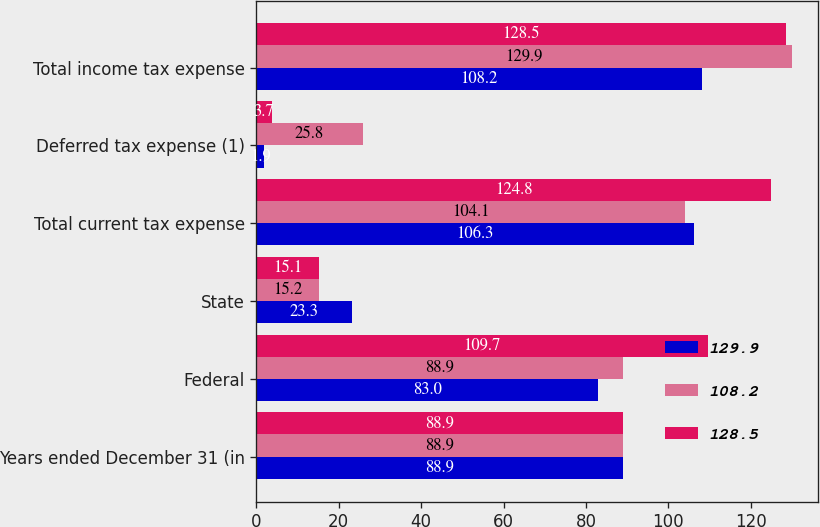Convert chart. <chart><loc_0><loc_0><loc_500><loc_500><stacked_bar_chart><ecel><fcel>Years ended December 31 (in<fcel>Federal<fcel>State<fcel>Total current tax expense<fcel>Deferred tax expense (1)<fcel>Total income tax expense<nl><fcel>129.9<fcel>88.9<fcel>83<fcel>23.3<fcel>106.3<fcel>1.9<fcel>108.2<nl><fcel>108.2<fcel>88.9<fcel>88.9<fcel>15.2<fcel>104.1<fcel>25.8<fcel>129.9<nl><fcel>128.5<fcel>88.9<fcel>109.7<fcel>15.1<fcel>124.8<fcel>3.7<fcel>128.5<nl></chart> 